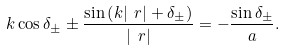Convert formula to latex. <formula><loc_0><loc_0><loc_500><loc_500>k \cos \delta _ { \pm } \pm \frac { \sin \left ( k | \ r | + \delta _ { \pm } \right ) } { | \ r | } = - \frac { \sin \delta _ { \pm } } { a } .</formula> 